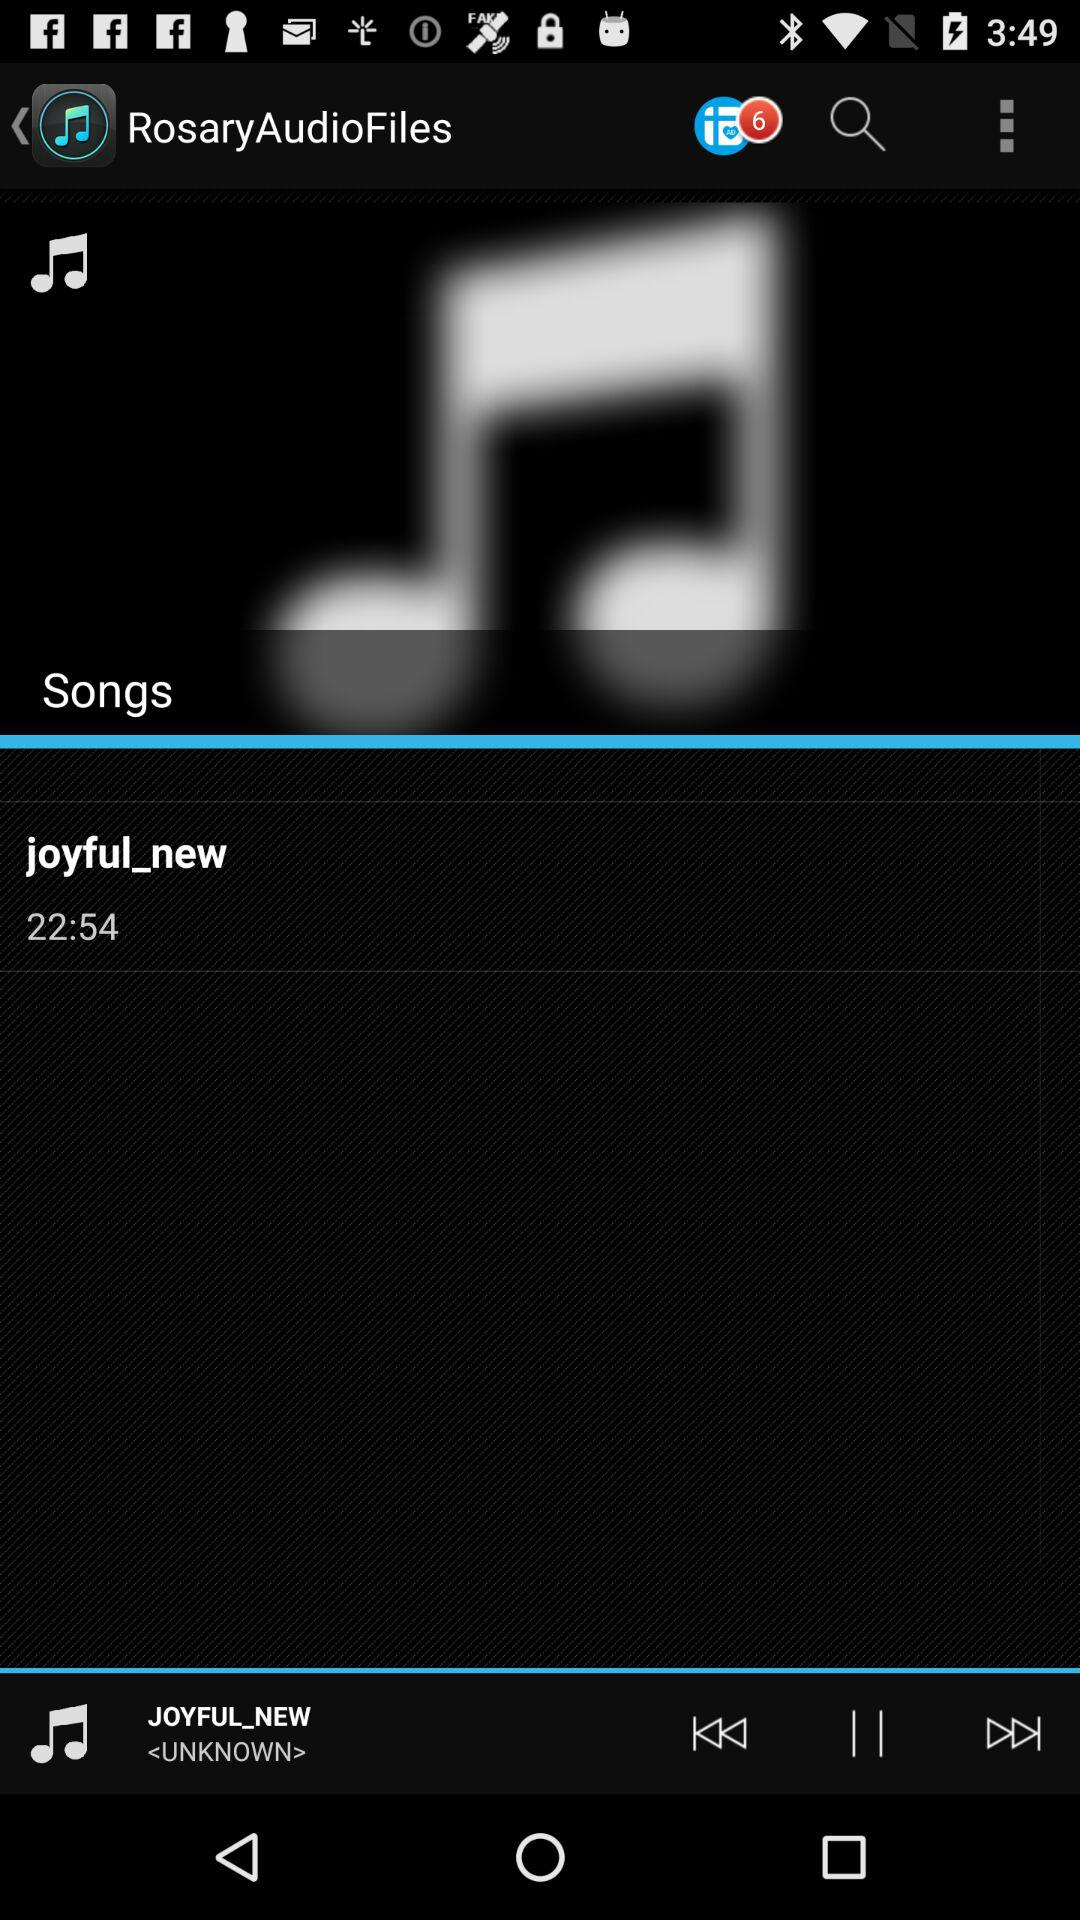How many messages are unread? The unread messages are 6. 